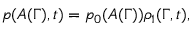<formula> <loc_0><loc_0><loc_500><loc_500>p ( A ( \Gamma ) , t ) = p _ { 0 } ( A ( \Gamma ) ) \rho _ { 1 } ( \Gamma , t ) ,</formula> 